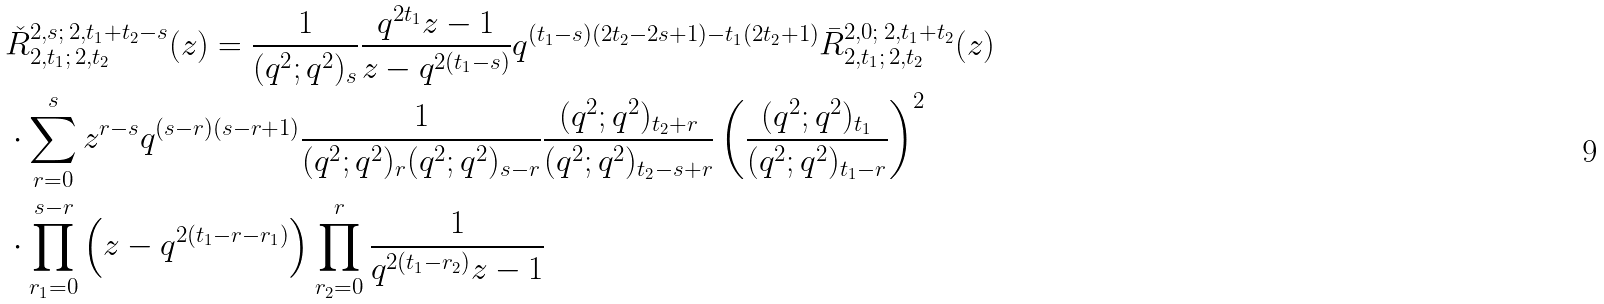Convert formula to latex. <formula><loc_0><loc_0><loc_500><loc_500>& \check { R } _ { 2 , t _ { 1 } ; \, 2 , t _ { 2 } } ^ { 2 , s ; \, 2 , t _ { 1 } + t _ { 2 } - s } ( z ) = \frac { 1 } { ( q ^ { 2 } ; q ^ { 2 } ) _ { s } } \frac { q ^ { 2 t _ { 1 } } z - 1 } { z - q ^ { 2 ( t _ { 1 } - s ) } } q ^ { ( t _ { 1 } - s ) ( 2 t _ { 2 } - 2 s + 1 ) - t _ { 1 } ( 2 t _ { 2 } + 1 ) } \bar { R } _ { 2 , t _ { 1 } ; \, 2 , t _ { 2 } } ^ { 2 , 0 ; \, 2 , t _ { 1 } + t _ { 2 } } ( z ) \\ & \cdot \sum _ { r = 0 } ^ { s } z ^ { r - s } q ^ { ( s - r ) ( s - r + 1 ) } \frac { 1 } { ( q ^ { 2 } ; q ^ { 2 } ) _ { r } ( q ^ { 2 } ; q ^ { 2 } ) _ { s - r } } \frac { ( q ^ { 2 } ; q ^ { 2 } ) _ { t _ { 2 } + r } } { ( q ^ { 2 } ; q ^ { 2 } ) _ { t _ { 2 } - s + r } } \left ( \frac { ( q ^ { 2 } ; q ^ { 2 } ) _ { t _ { 1 } } } { ( q ^ { 2 } ; q ^ { 2 } ) _ { t _ { 1 } - r } } \right ) ^ { 2 } \\ & \cdot \prod _ { r _ { 1 } = 0 } ^ { s - r } \left ( z - q ^ { 2 ( t _ { 1 } - r - r _ { 1 } ) } \right ) \prod _ { r _ { 2 } = 0 } ^ { r } \frac { 1 } { q ^ { 2 ( t _ { 1 } - r _ { 2 } ) } z - 1 }</formula> 